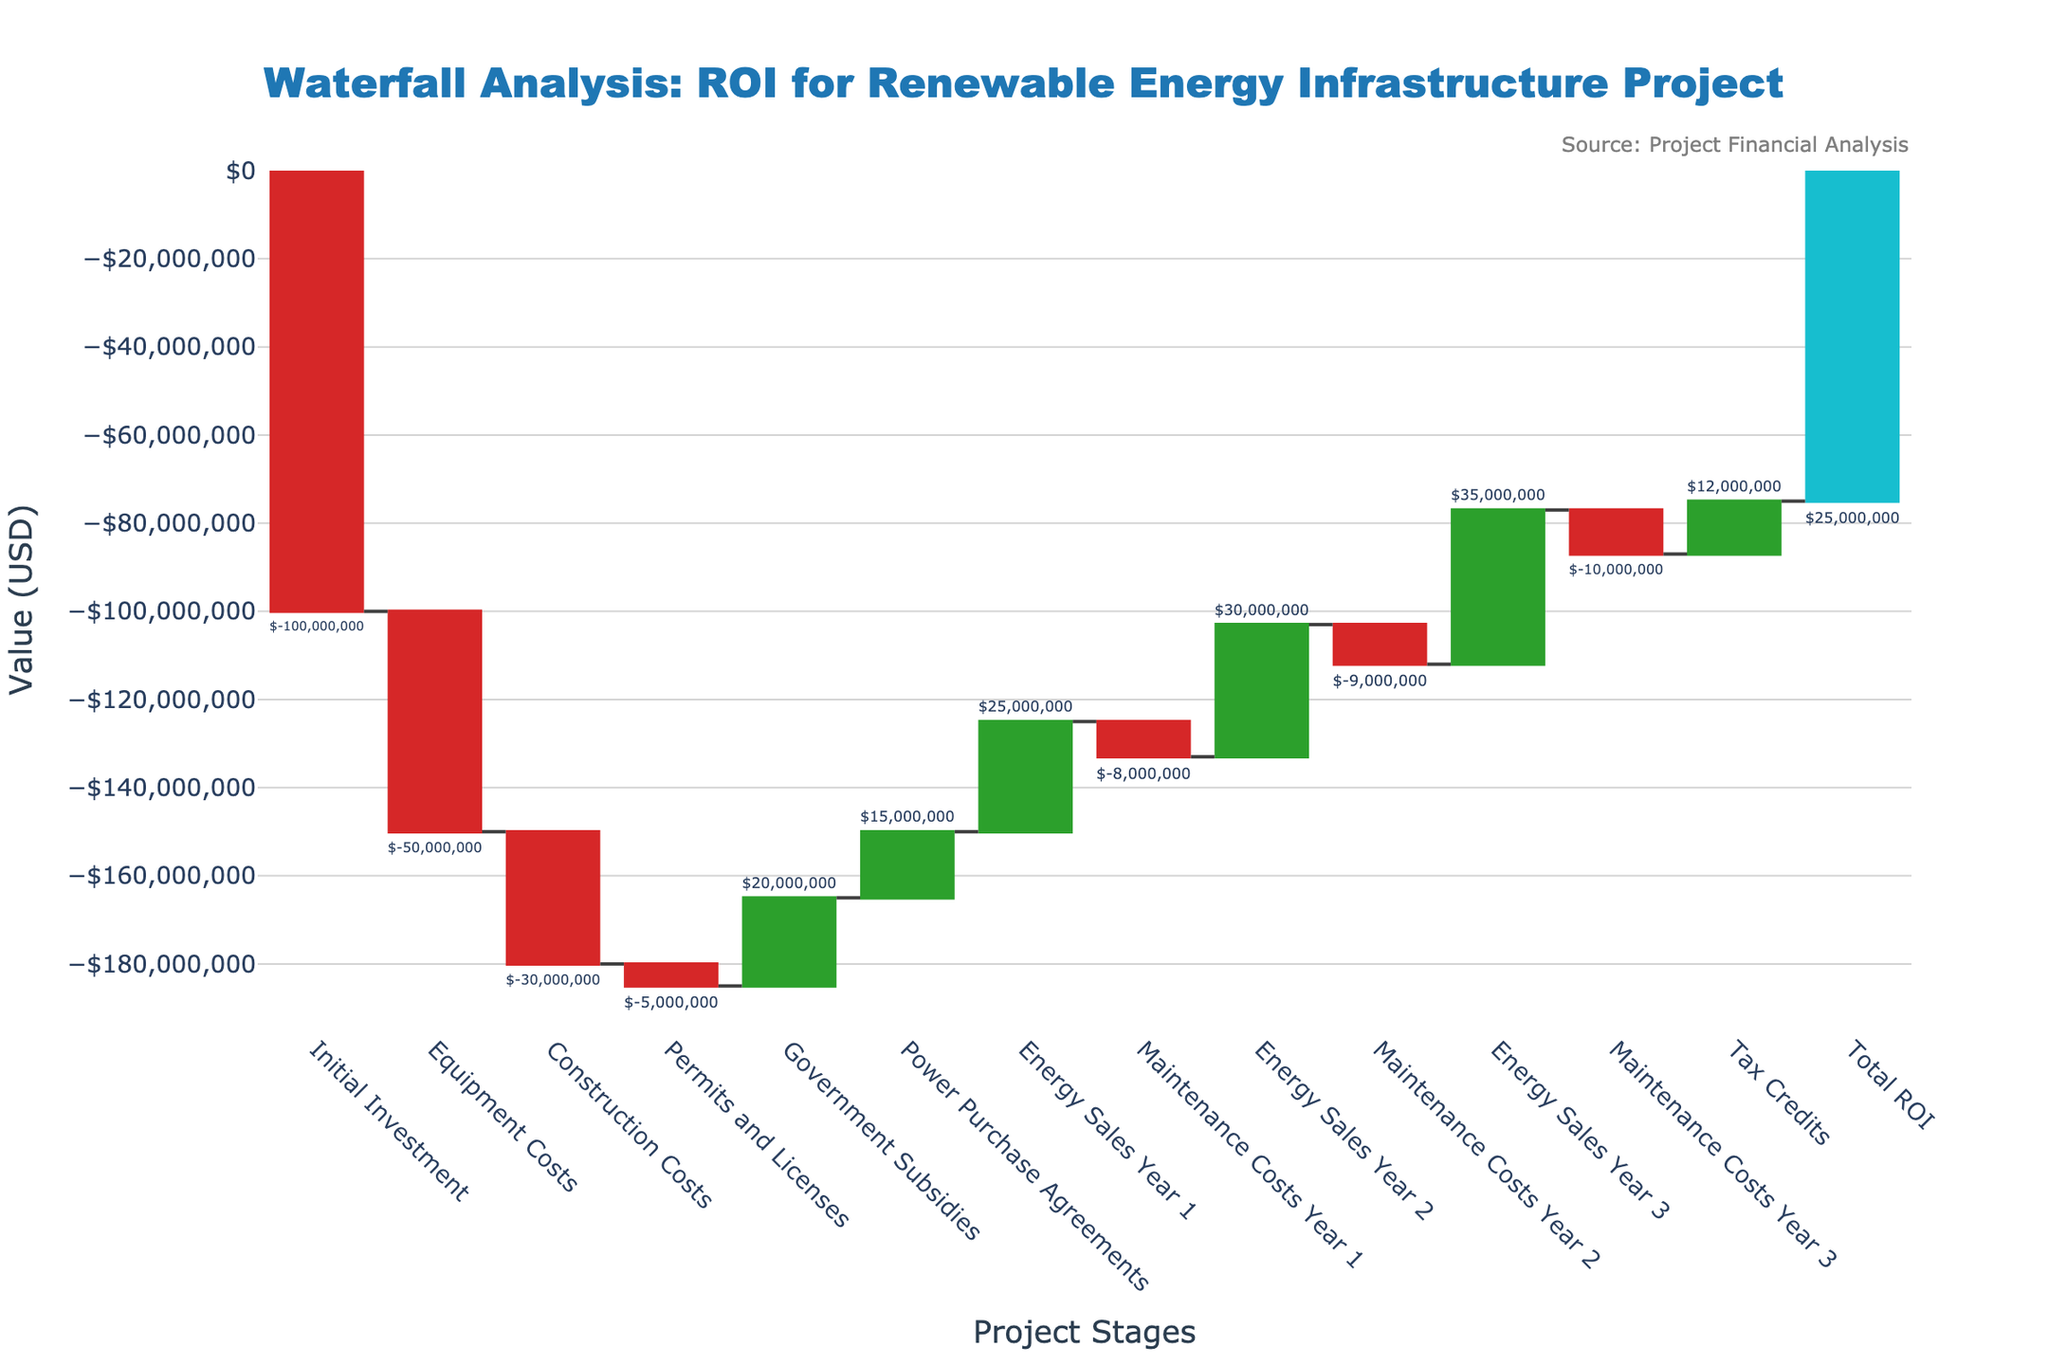How much was the initial investment for the renewable energy infrastructure project? The initial investment value is represented in the first section of the waterfall chart. It shows a negative value of $100,000,000.
Answer: -$100,000,000 What were the equipment and construction costs combined? The waterfall chart shows the equipment costs as -$50,000,000 and the construction costs as -$30,000,000. Adding them together gives -$50,000,000 + -$30,000,000 = -$80,000,000.
Answer: -$80,000,000 What is the total positive impact of government subsidies and tax credits on the project? From the chart, government subsidies are $20,000,000, and tax credits are $12,000,000. Adding them together gives $20,000,000 + $12,000,000 = $32,000,000.
Answer: $32,000,000 Which revenue source brings the highest contribution within the first three years of energy sales? The waterfall chart lists the energy sales for Year 1 as $25,000,000, Year 2 as $30,000,000, and Year 3 as $35,000,000. Among these, Year 3 has the highest contribution of $35,000,000.
Answer: $35,000,000 How do the yearly maintenance costs compare in their first, second, and third years? According to the chart, maintenance costs for Year 1 are -$8,000,000, for Year 2 they are -$9,000,000, and for Year 3 they are -$10,000,000. The costs increase each year.
Answer: increases each year What is the net effect of the power purchase agreements on the return on investment? The waterall chart shows an increase of $15,000,000 for power purchase agreements, indicating a positive impact on ROI.
Answer: $15,000,000 positive impact What is indicated by the final segment labeled 'Total ROI'? The final segment of the waterfall chart, labeled 'Total ROI', indicates the overall return on investment for the project after accounting for all the costs and revenues. The value is $25,000,000.
Answer: $25,000,000 If we exclude the initial investment, what is the net ROI from all subsequent project activities? Excluding the initial investment of -$100,000,000, compute the net ROI by summing the remaining values: -$50,000,000 (equipment) -$30,000,000 (construction) -$5,000,000 (permits) +$20,000,000 (subsidies) +$15,000,000 (agreements) +$25,000,000 (sales year 1) -$8,000,000 (maintenance year 1) +$30,000,000 (sales year 2) -$9,000,000 (maintenance year 2) +$35,000,000 (sales year 3) -$10,000,000 (maintenance year 3) +$12,000,000 (tax credits). Summing these gives -$10,000,000.
Answer: -$10,000,000 What stage had the smallest negative financial impact? Permits and licenses had the smallest negative financial impact at -$5,000,000, as shown in the waterfall chart.
Answer: -$5,000,000 How does the maintenance cost trend affect the net positive impact of energy sales over the three years? Over the three years, maintenance costs increased from -$8,000,000 to -$10,000,000, whereas energy sales increased from $25,000,000 to $35,000,000. Despite rising maintenance costs, the increasing energy sales ensured a positive net impact.
Answer: Positive net impact despite rising maintenance costs 